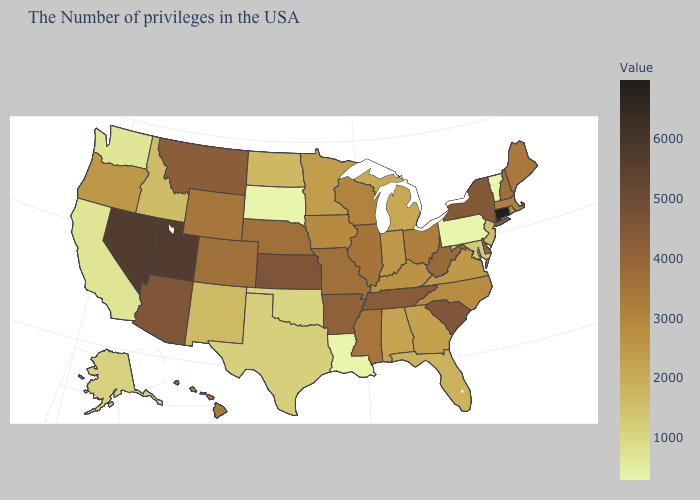Does the map have missing data?
Concise answer only. No. Does Texas have a lower value than Nebraska?
Concise answer only. Yes. Among the states that border New Mexico , does Utah have the highest value?
Short answer required. Yes. 